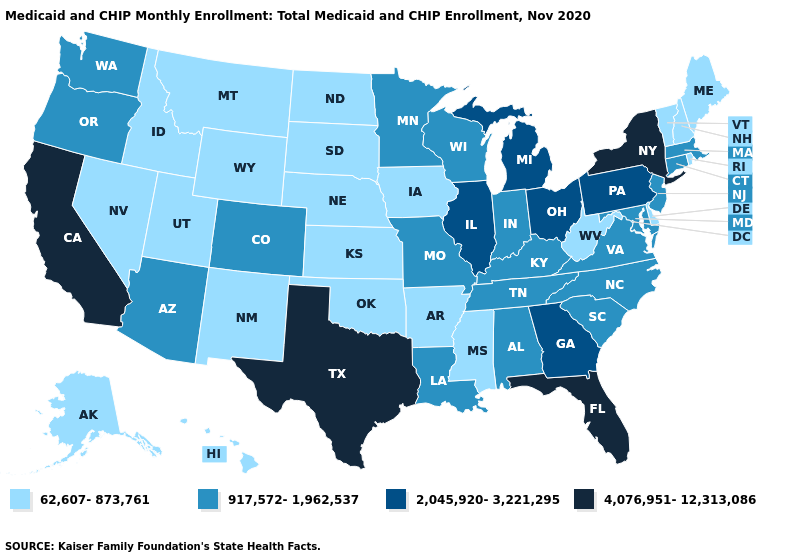Among the states that border Mississippi , does Arkansas have the lowest value?
Be succinct. Yes. What is the value of Virginia?
Write a very short answer. 917,572-1,962,537. What is the value of Wyoming?
Be succinct. 62,607-873,761. What is the highest value in the South ?
Concise answer only. 4,076,951-12,313,086. What is the lowest value in the West?
Keep it brief. 62,607-873,761. Is the legend a continuous bar?
Short answer required. No. What is the lowest value in the USA?
Be succinct. 62,607-873,761. What is the value of Alabama?
Quick response, please. 917,572-1,962,537. Among the states that border Massachusetts , which have the lowest value?
Write a very short answer. New Hampshire, Rhode Island, Vermont. Among the states that border Tennessee , which have the highest value?
Write a very short answer. Georgia. Name the states that have a value in the range 4,076,951-12,313,086?
Quick response, please. California, Florida, New York, Texas. Which states have the highest value in the USA?
Give a very brief answer. California, Florida, New York, Texas. Does Texas have the highest value in the South?
Write a very short answer. Yes. What is the highest value in states that border Indiana?
Keep it brief. 2,045,920-3,221,295. Does Vermont have the same value as South Carolina?
Answer briefly. No. 